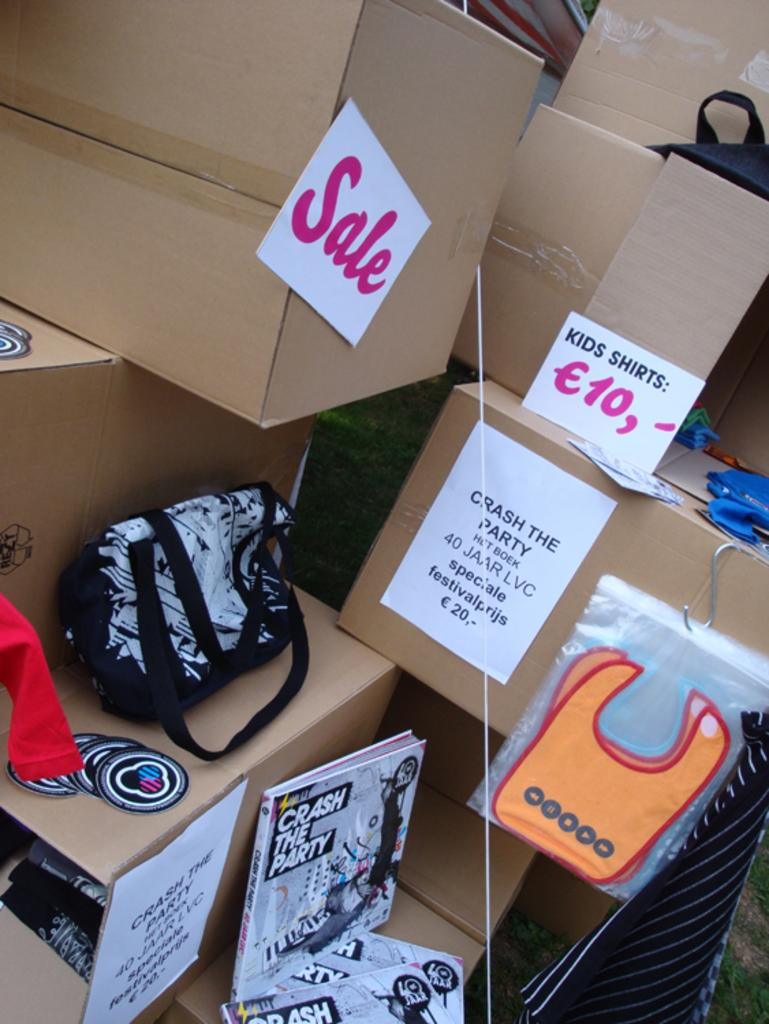<image>
Describe the image concisely. boxes on top of boxes with one labeled with a white paper that says 'sale' in pink on it 